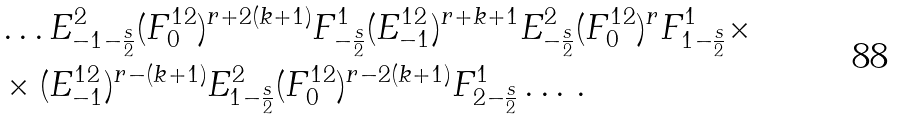Convert formula to latex. <formula><loc_0><loc_0><loc_500><loc_500>& \dots E ^ { 2 } _ { - 1 - \frac { s } { 2 } } ( F ^ { 1 2 } _ { 0 } ) ^ { r + 2 ( k + 1 ) } F ^ { 1 } _ { - \frac { s } { 2 } } ( E ^ { 1 2 } _ { - 1 } ) ^ { r + k + 1 } E ^ { 2 } _ { - \frac { s } { 2 } } ( F ^ { 1 2 } _ { 0 } ) ^ { r } F ^ { 1 } _ { 1 - \frac { s } { 2 } } \times \\ & \times ( E ^ { 1 2 } _ { - 1 } ) ^ { r - ( k + 1 ) } E ^ { 2 } _ { 1 - \frac { s } { 2 } } ( F ^ { 1 2 } _ { 0 } ) ^ { r - 2 ( k + 1 ) } F ^ { 1 } _ { 2 - \frac { s } { 2 } } \dots \, .</formula> 